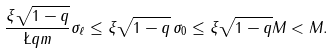<formula> <loc_0><loc_0><loc_500><loc_500>\frac { \xi \sqrt { 1 - q } } { \L q m } \sigma _ { \ell } \leq \xi \sqrt { 1 - q } \, \sigma _ { 0 } \leq \xi \sqrt { 1 - q } M < M .</formula> 